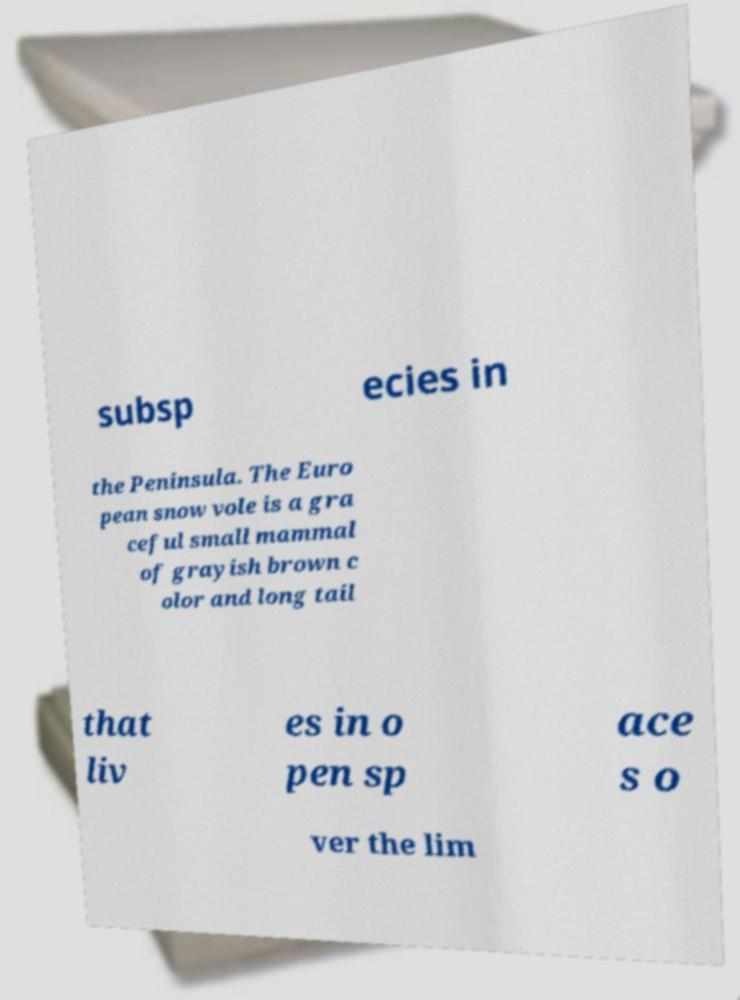There's text embedded in this image that I need extracted. Can you transcribe it verbatim? subsp ecies in the Peninsula. The Euro pean snow vole is a gra ceful small mammal of grayish brown c olor and long tail that liv es in o pen sp ace s o ver the lim 